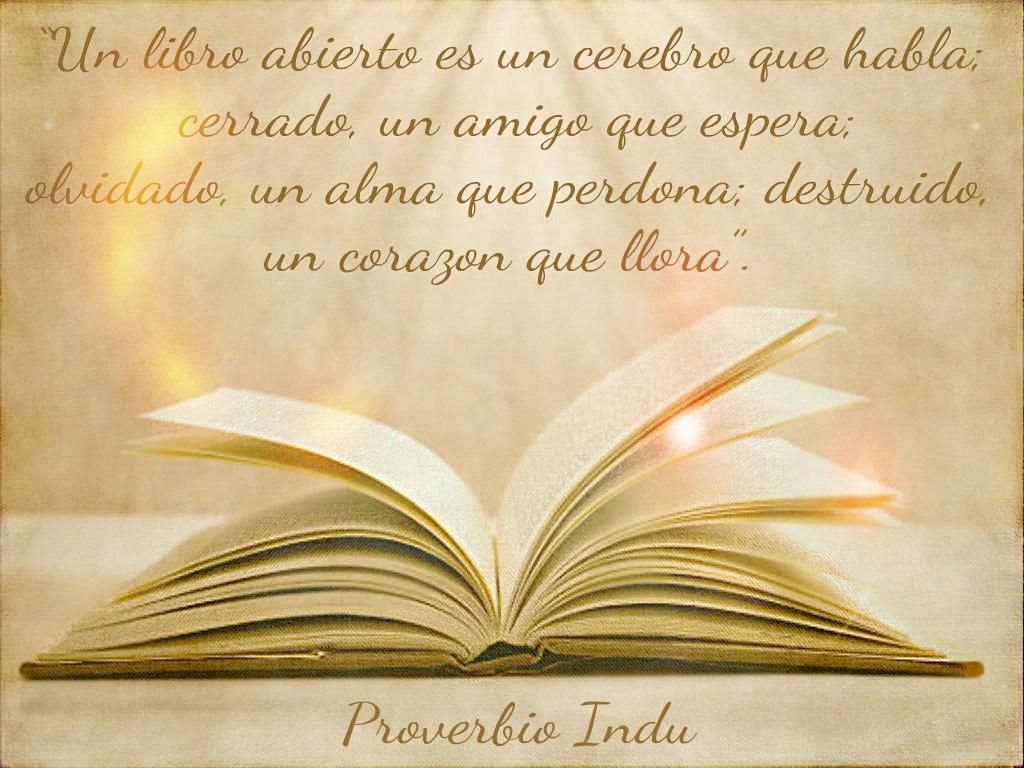What words are below the book?
Keep it short and to the point. Proverbio indu. What is the first word?
Provide a succinct answer. Un. 